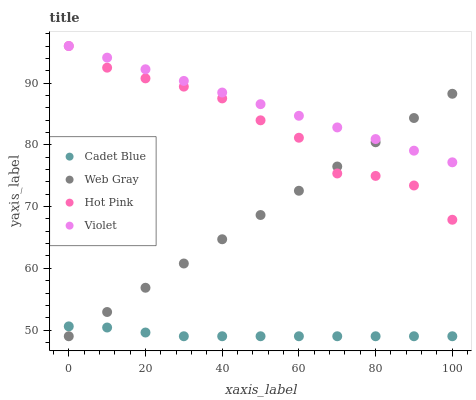Does Cadet Blue have the minimum area under the curve?
Answer yes or no. Yes. Does Violet have the maximum area under the curve?
Answer yes or no. Yes. Does Web Gray have the minimum area under the curve?
Answer yes or no. No. Does Web Gray have the maximum area under the curve?
Answer yes or no. No. Is Web Gray the smoothest?
Answer yes or no. Yes. Is Hot Pink the roughest?
Answer yes or no. Yes. Is Cadet Blue the smoothest?
Answer yes or no. No. Is Cadet Blue the roughest?
Answer yes or no. No. Does Cadet Blue have the lowest value?
Answer yes or no. Yes. Does Hot Pink have the lowest value?
Answer yes or no. No. Does Hot Pink have the highest value?
Answer yes or no. Yes. Does Web Gray have the highest value?
Answer yes or no. No. Is Cadet Blue less than Hot Pink?
Answer yes or no. Yes. Is Hot Pink greater than Cadet Blue?
Answer yes or no. Yes. Does Web Gray intersect Cadet Blue?
Answer yes or no. Yes. Is Web Gray less than Cadet Blue?
Answer yes or no. No. Is Web Gray greater than Cadet Blue?
Answer yes or no. No. Does Cadet Blue intersect Hot Pink?
Answer yes or no. No. 